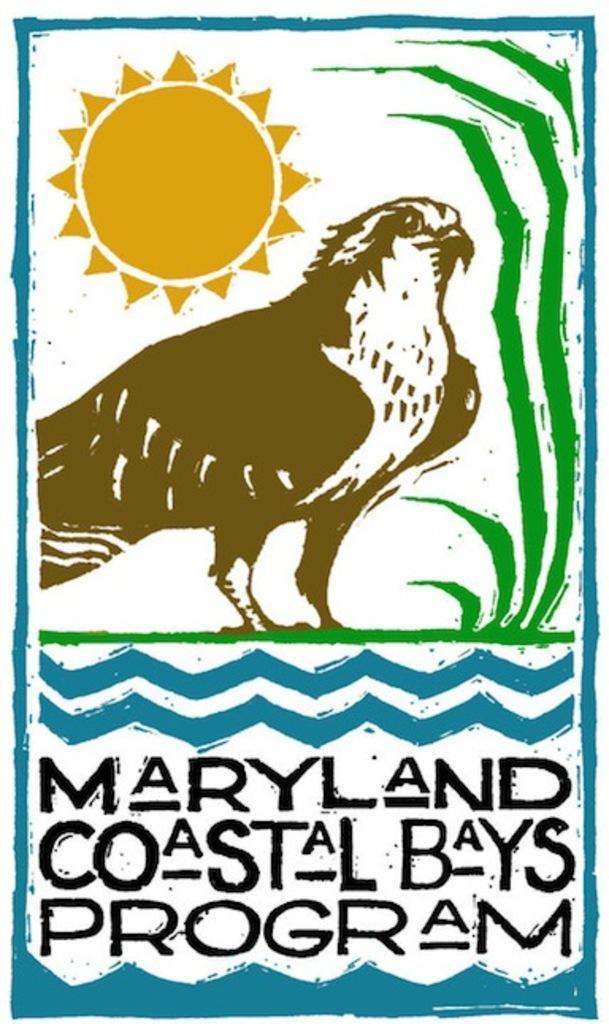Please provide a concise description of this image. Here we can see a painting of a bird,plant and sun and at the bottom there are texts written on the image. 